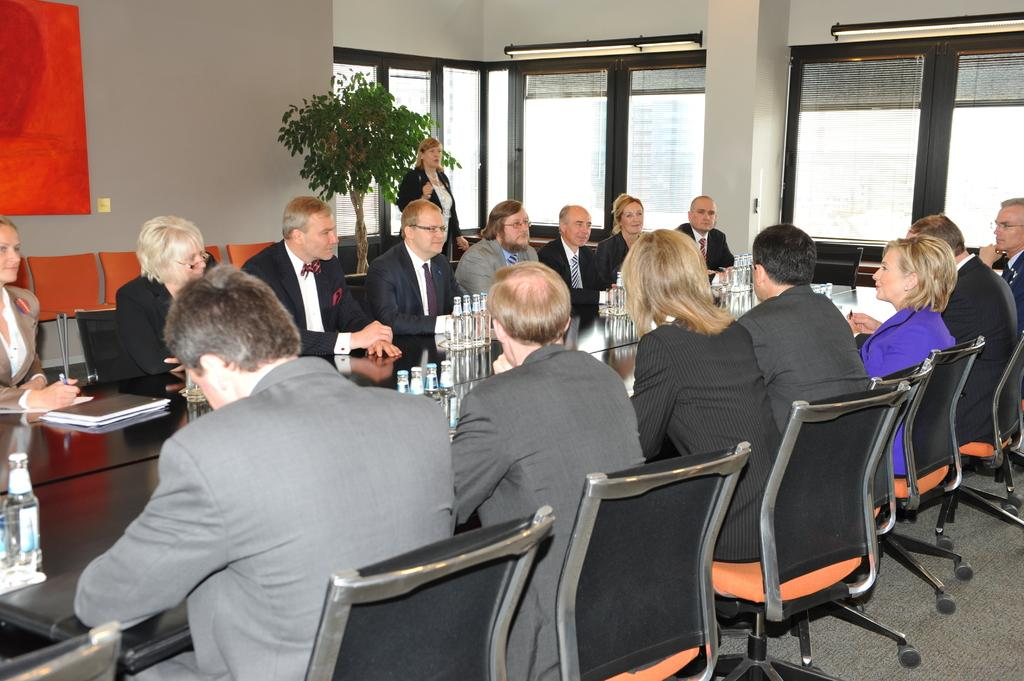How many people are in the image? There is a group of people in the image. What are the people doing in the image? The people are sitting in front of a table. What can be seen in the background of the image? There is a wall and a plant in the background of the image. Is there anyone else visible in the background of the image? Yes, there is a lady standing in the background of the image. What type of vegetable is being grown in the nest in the image? There is no vegetable or nest present in the image. How many chickens are visible in the image? There are no chickens present in the image. 